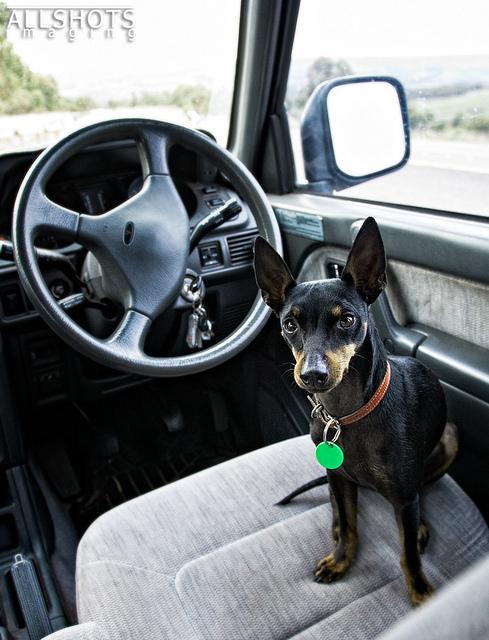What is the dog thinking?
Short answer required. Nothing. Is this dog in a car?
Answer briefly. Yes. Is the dog driving?
Be succinct. No. 